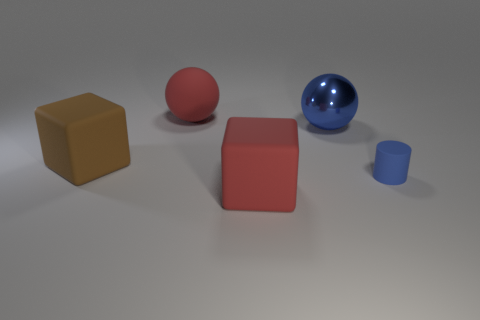Add 4 big metallic cylinders. How many objects exist? 9 Subtract 2 blocks. How many blocks are left? 0 Subtract all cylinders. How many objects are left? 4 Subtract 0 brown cylinders. How many objects are left? 5 Subtract all yellow spheres. Subtract all cyan cubes. How many spheres are left? 2 Subtract all small purple blocks. Subtract all balls. How many objects are left? 3 Add 5 large matte things. How many large matte things are left? 8 Add 4 large things. How many large things exist? 8 